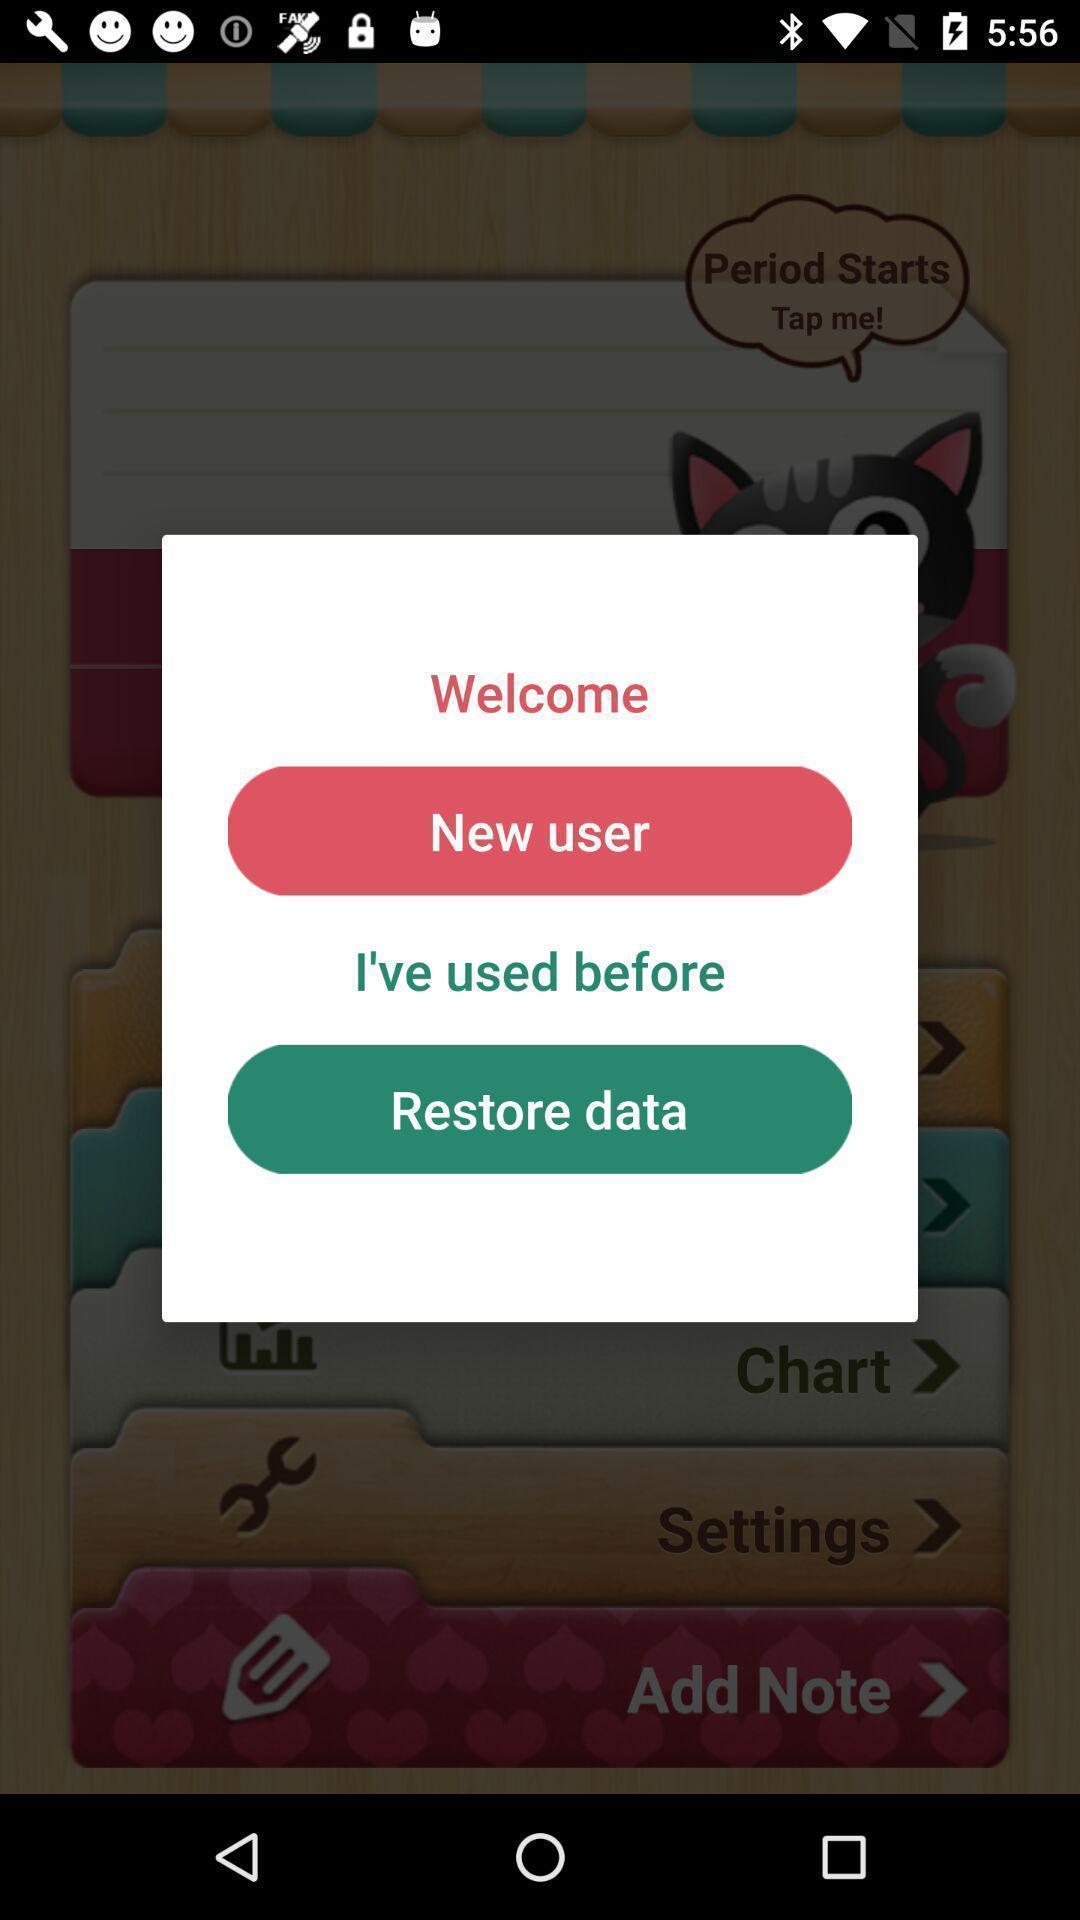Provide a detailed account of this screenshot. Pop-up shows multiple options. 